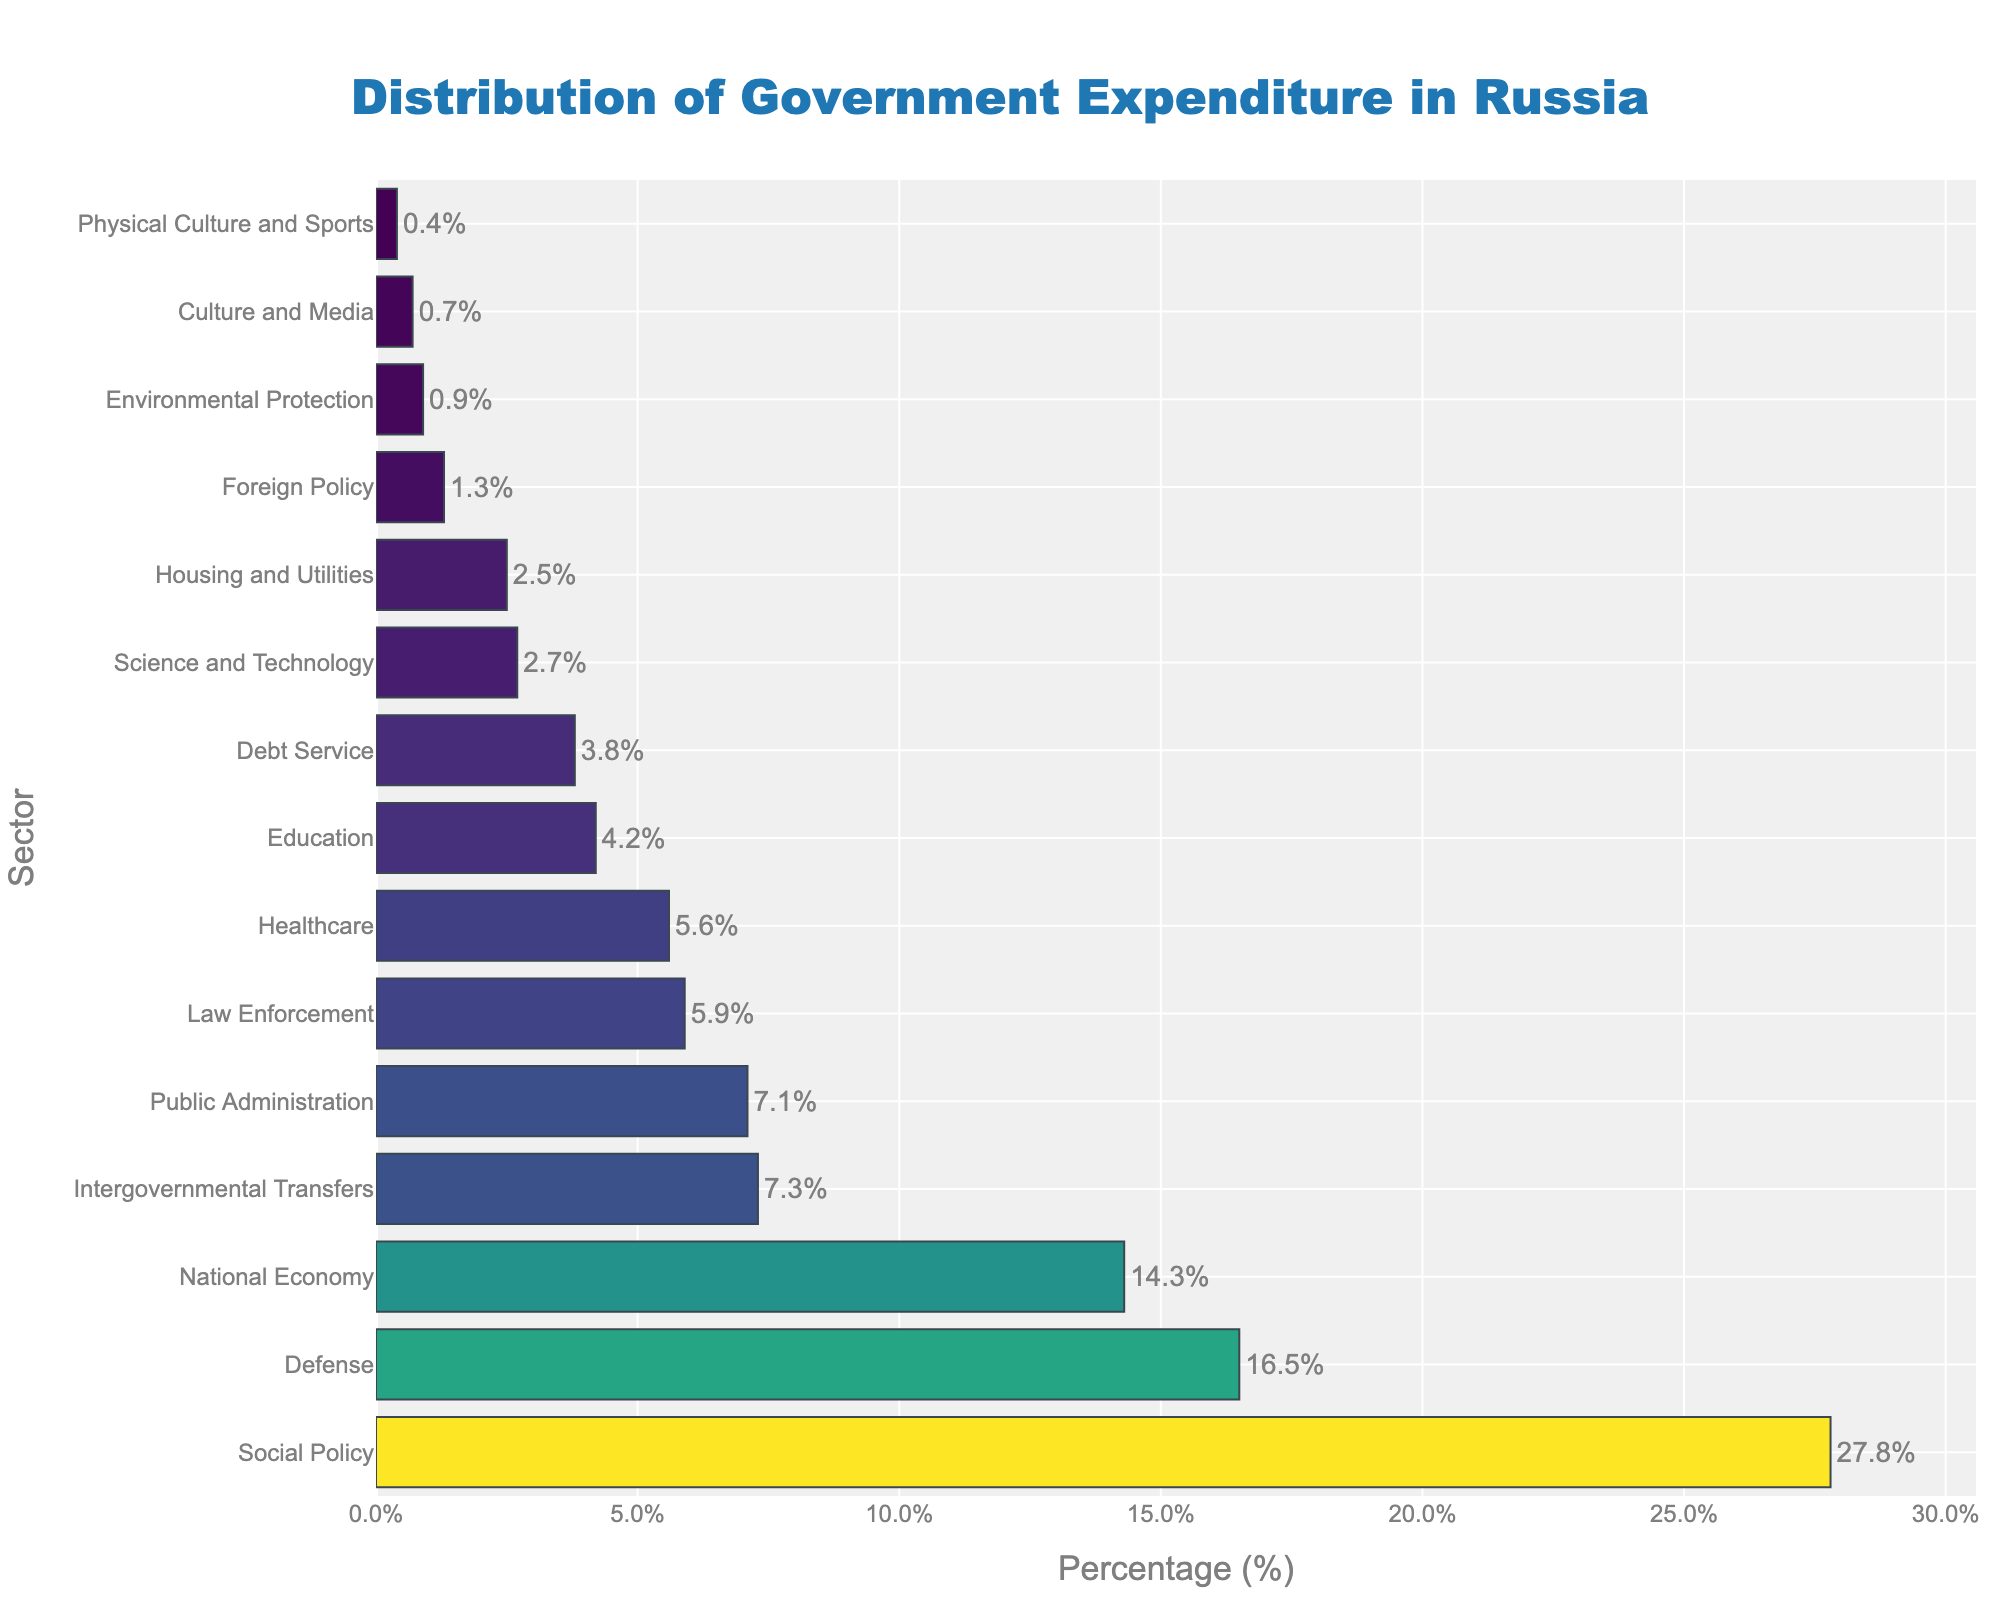What sector has the highest percentage of government expenditure? The highest bar corresponds to the sector 'Social Policy' with a length indicating 27.8%.
Answer: Social Policy Which sector receives the least funding? The shortest bar corresponds to the sector 'Physical Culture and Sports' with a value of 0.4%.
Answer: Physical Culture and Sports How much more percentage of expenditure does Defense receive compared to Healthcare? 'Defense' has 16.5% and 'Healthcare' has 5.6%. Calculating the difference: 16.5% - 5.6% = 10.9%.
Answer: 10.9% Which sectors have a percentage of expenditure greater than or equal to 10%? The sectors with bars extending to or beyond 10% are 'Defense', 'Social Policy', and 'National Economy', with 16.5%, 27.8%, and 14.3% respectively.
Answer: Defense, Social Policy, National Economy How does the expenditure on Education compare to that on Debt Service? 'Education' has 4.2% and 'Debt Service' has 3.8%. Since 4.2% is greater than 3.8%, more is spent on Education than on Debt Service.
Answer: Education is higher What is the combined expenditure percentage for Law Enforcement and Healthcare? 'Law Enforcement' has 5.9% and 'Healthcare' has 5.6%. Adding them yields: 5.9% + 5.6% = 11.5%.
Answer: 11.5% Which sector has a percentage just under 5%? The bar just under 5% corresponds to 'Education', which has a percentage of 4.2%.
Answer: Education Are there more sectors with expenditures over 10% or under 5%? There are three sectors over 10%: Defense, Social Policy, and National Economy. There are nine sectors under 5%: Healthcare, Education, Debt Service, Housing and Utilities, Environmental Protection, Culture and Media, Physical Culture and Sports, Foreign Policy, and Science and Technology.
Answer: Under 5% What is the percentage difference between the sectors Public Administration and Intergovernmental Transfers? 'Public Administration' has 7.1% and 'Intergovernmental Transfers' has 7.3%. The difference is: 7.3% - 7.1% = 0.2%.
Answer: 0.2% Which sector receives slightly more funding than Housing and Utilities? 'Housing and Utilities' has 2.5%. 'Science and Technology', which is next in line, has a percentage of 2.7%, slightly higher.
Answer: Science and Technology 